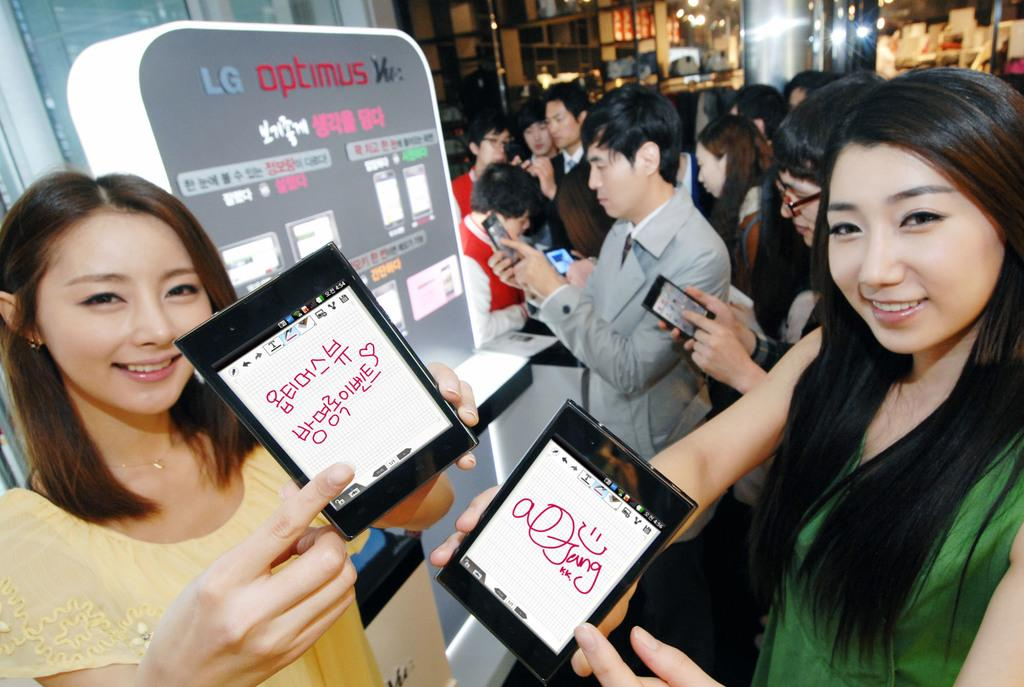What is happening in the image? There are persons standing in the image, and they are looking at posters of optimums. What can be seen in the background of the image? There are racks in the background of the image, and there is light visible. Can you describe the posters in the image? The posters in the image feature optimums. What type of cloud can be seen in the image? There is no cloud present in the image. What is the chance of rain in the image? The image does not provide any information about the weather or the chance of rain. 